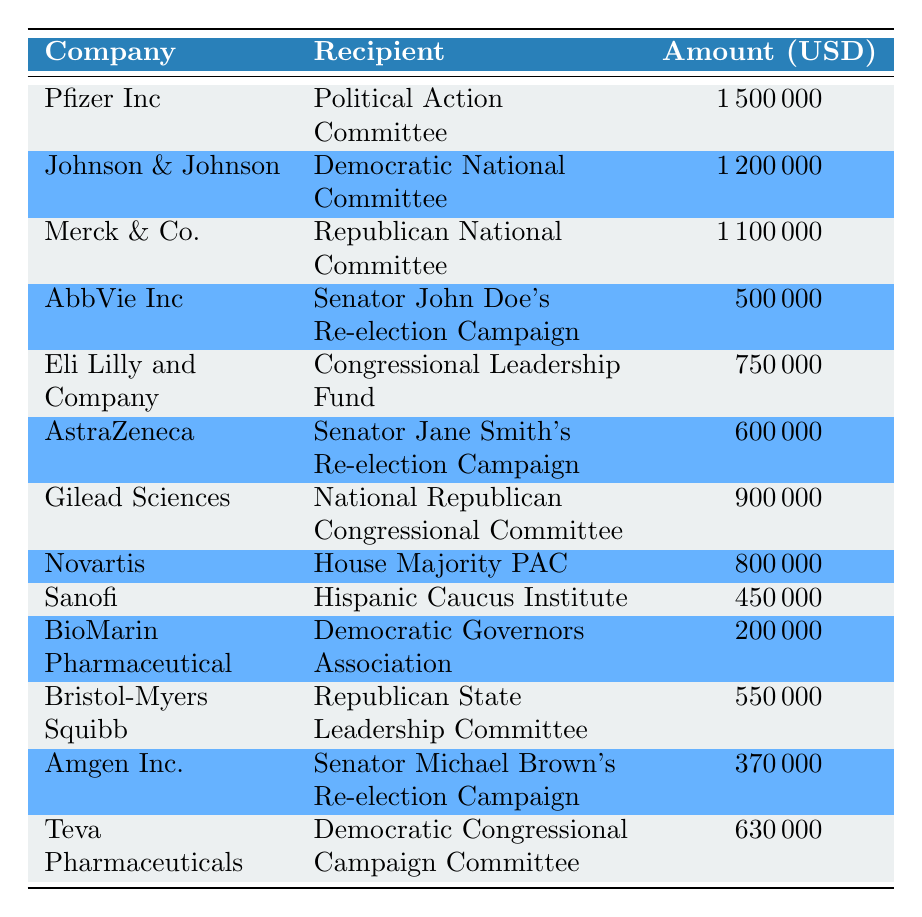What was the highest contribution amount made by a pharmaceutical company? The highest contribution amount shown in the table is by Pfizer Inc, which donated 1,500,000 USD to the Political Action Committee.
Answer: 1,500,000 USD How much did Johnson & Johnson contribute in 2021? Johnson & Johnson contributed 1,200,000 USD to the Democratic National Committee as listed in the table.
Answer: 1,200,000 USD Did AbbVie Inc donate to a political campaign in 2021? Yes, AbbVie Inc donated 500,000 USD to Senator John Doe's re-election campaign, confirming that they did make a political contribution.
Answer: Yes Which company contributed to the Hispanic Caucus Institute? Sanofi contributed 450,000 USD to the Hispanic Caucus Institute as per the data in the table.
Answer: Sanofi What is the total amount contributed by the companies to the Republican National Committee and the Democratic National Committee? The total contribution to the Republican National Committee is 1,100,000 USD (Merck & Co.) and to the Democratic National Committee is 1,200,000 USD (Johnson & Johnson). Summing these gives 1,100,000 + 1,200,000 = 2,300,000 USD.
Answer: 2,300,000 USD Which pharmaceutical company made a contribution of 630,000 USD, and to whom was it given? Teva Pharmaceuticals made a contribution of 630,000 USD to the Democratic Congressional Campaign Committee, as noted in the table.
Answer: Teva Pharmaceuticals; Democratic Congressional Campaign Committee Is there any company that donated more than 1 million USD? Yes, there are three companies: Pfizer Inc (1,500,000 USD), Johnson & Johnson (1,200,000 USD), and Merck & Co. (1,100,000 USD) that donated more than 1 million USD.
Answer: Yes What is the average contribution amount from the given companies? The total amount contributed is 7,850,000 USD (sum of all contributions). Since there are 13 contributions, the average is 7,850,000/13 = 603,846.15 USD, which rounds to 604,000 USD.
Answer: 604,000 USD 